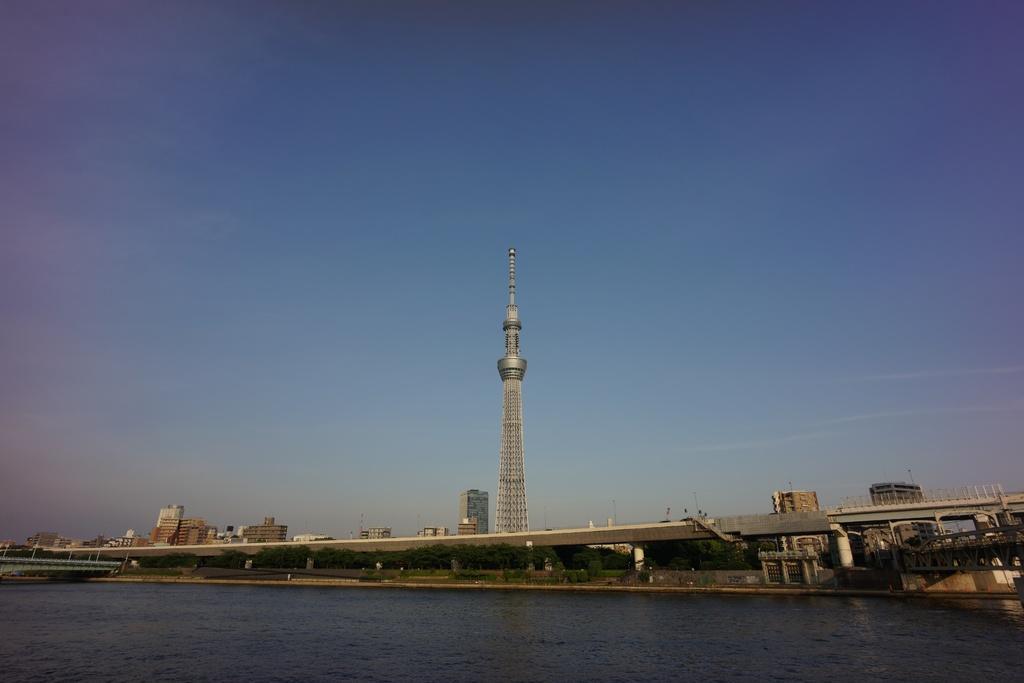Could you give a brief overview of what you see in this image? In this picture we can see water, trees and a bridge and behind the bridge there is a tower, buildings and a sky. 